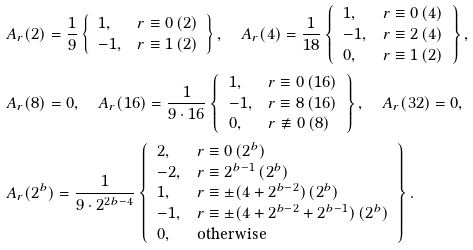Convert formula to latex. <formula><loc_0><loc_0><loc_500><loc_500>& A _ { r } ( 2 ) = \frac { 1 } { 9 } \left \{ \begin{array} { l l } 1 , & r \equiv 0 \, ( 2 ) \\ - 1 , & r \equiv 1 \, ( 2 ) \end{array} \right \} , \quad A _ { r } ( 4 ) = \frac { 1 } { 1 8 } \left \{ \begin{array} { l l } 1 , & r \equiv 0 \, ( 4 ) \\ - 1 , & r \equiv 2 \, ( 4 ) \\ 0 , & r \equiv 1 \, ( 2 ) \end{array} \right \} , \\ & A _ { r } ( 8 ) = 0 , \quad A _ { r } ( 1 6 ) = \frac { 1 } { 9 \cdot 1 6 } \left \{ \begin{array} { l l } 1 , & r \equiv 0 \, ( 1 6 ) \\ - 1 , & r \equiv 8 \, ( 1 6 ) \\ 0 , & r \not \equiv 0 \, ( 8 ) \end{array} \right \} , \quad A _ { r } ( 3 2 ) = 0 , \\ & A _ { r } ( 2 ^ { b } ) = \frac { 1 } { 9 \cdot 2 ^ { 2 b - 4 } } \left \{ \begin{array} { l l } 2 , & r \equiv 0 \, ( 2 ^ { b } ) \\ - 2 , & r \equiv 2 ^ { b - 1 } \, ( 2 ^ { b } ) \\ 1 , & r \equiv \pm ( 4 + 2 ^ { b - 2 } ) \, ( 2 ^ { b } ) \\ - 1 , & r \equiv \pm ( 4 + 2 ^ { b - 2 } + 2 ^ { b - 1 } ) \, ( 2 ^ { b } ) \\ 0 , & \text {otherwise} \end{array} \right \} .</formula> 